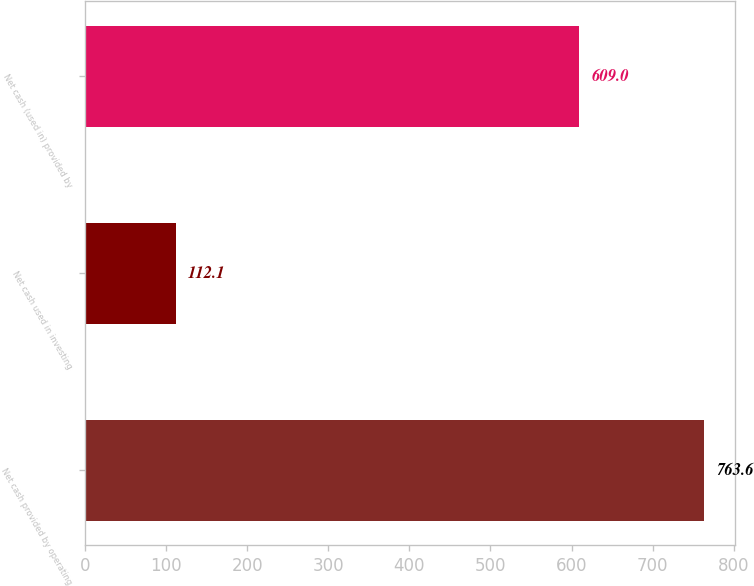<chart> <loc_0><loc_0><loc_500><loc_500><bar_chart><fcel>Net cash provided by operating<fcel>Net cash used in investing<fcel>Net cash (used in) provided by<nl><fcel>763.6<fcel>112.1<fcel>609<nl></chart> 